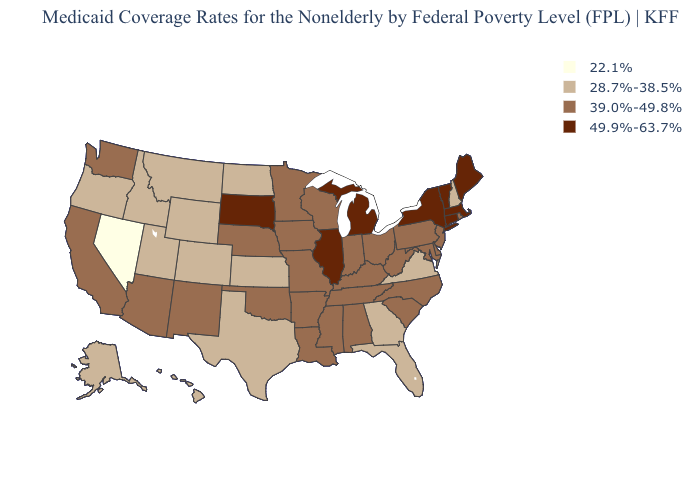Among the states that border Tennessee , which have the lowest value?
Short answer required. Georgia, Virginia. What is the value of Kansas?
Give a very brief answer. 28.7%-38.5%. Does Nebraska have a lower value than Michigan?
Give a very brief answer. Yes. What is the lowest value in the USA?
Answer briefly. 22.1%. Which states have the lowest value in the USA?
Concise answer only. Nevada. Name the states that have a value in the range 28.7%-38.5%?
Write a very short answer. Alaska, Colorado, Florida, Georgia, Hawaii, Idaho, Kansas, Montana, New Hampshire, North Dakota, Oregon, Texas, Utah, Virginia, Wyoming. Name the states that have a value in the range 22.1%?
Short answer required. Nevada. Is the legend a continuous bar?
Give a very brief answer. No. What is the highest value in the USA?
Short answer required. 49.9%-63.7%. Name the states that have a value in the range 39.0%-49.8%?
Concise answer only. Alabama, Arizona, Arkansas, California, Delaware, Indiana, Iowa, Kentucky, Louisiana, Maryland, Minnesota, Mississippi, Missouri, Nebraska, New Jersey, New Mexico, North Carolina, Ohio, Oklahoma, Pennsylvania, Rhode Island, South Carolina, Tennessee, Washington, West Virginia, Wisconsin. Among the states that border Montana , does Wyoming have the lowest value?
Concise answer only. Yes. What is the lowest value in the USA?
Give a very brief answer. 22.1%. Does Hawaii have the same value as Louisiana?
Concise answer only. No. What is the value of Missouri?
Write a very short answer. 39.0%-49.8%. What is the highest value in the USA?
Be succinct. 49.9%-63.7%. 